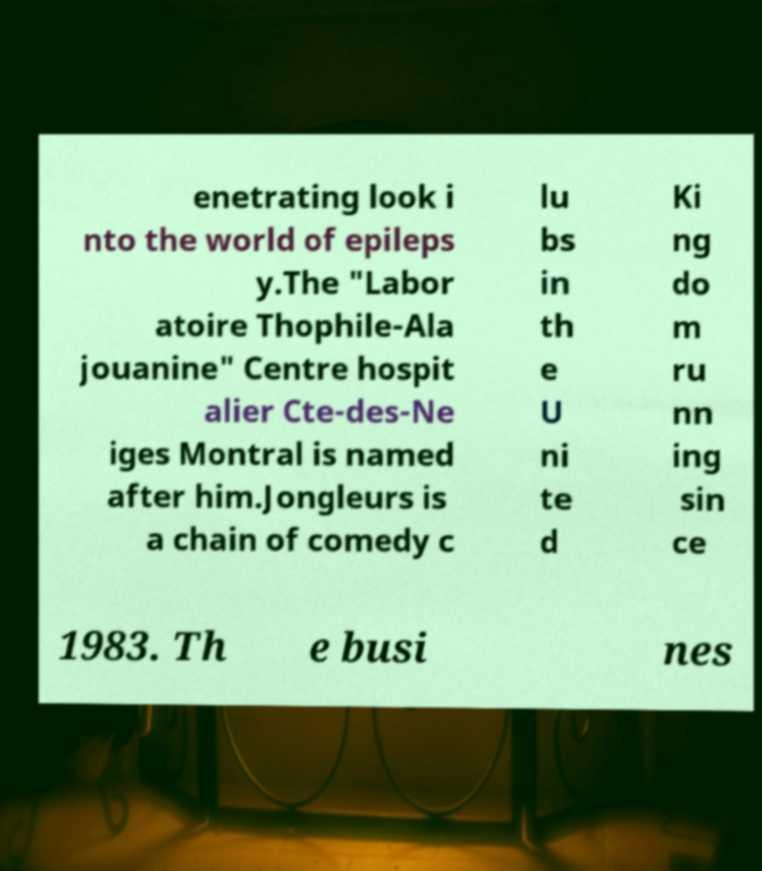What messages or text are displayed in this image? I need them in a readable, typed format. enetrating look i nto the world of epileps y.The "Labor atoire Thophile-Ala jouanine" Centre hospit alier Cte-des-Ne iges Montral is named after him.Jongleurs is a chain of comedy c lu bs in th e U ni te d Ki ng do m ru nn ing sin ce 1983. Th e busi nes 